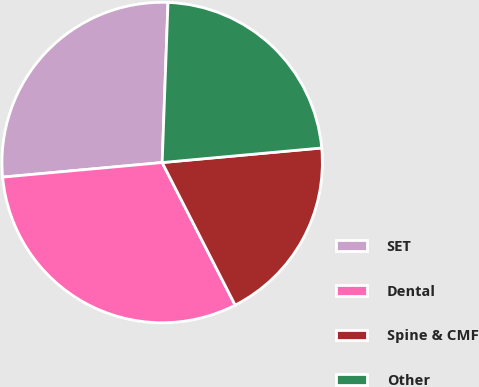Convert chart. <chart><loc_0><loc_0><loc_500><loc_500><pie_chart><fcel>SET<fcel>Dental<fcel>Spine & CMF<fcel>Other<nl><fcel>27.03%<fcel>31.08%<fcel>18.92%<fcel>22.97%<nl></chart> 